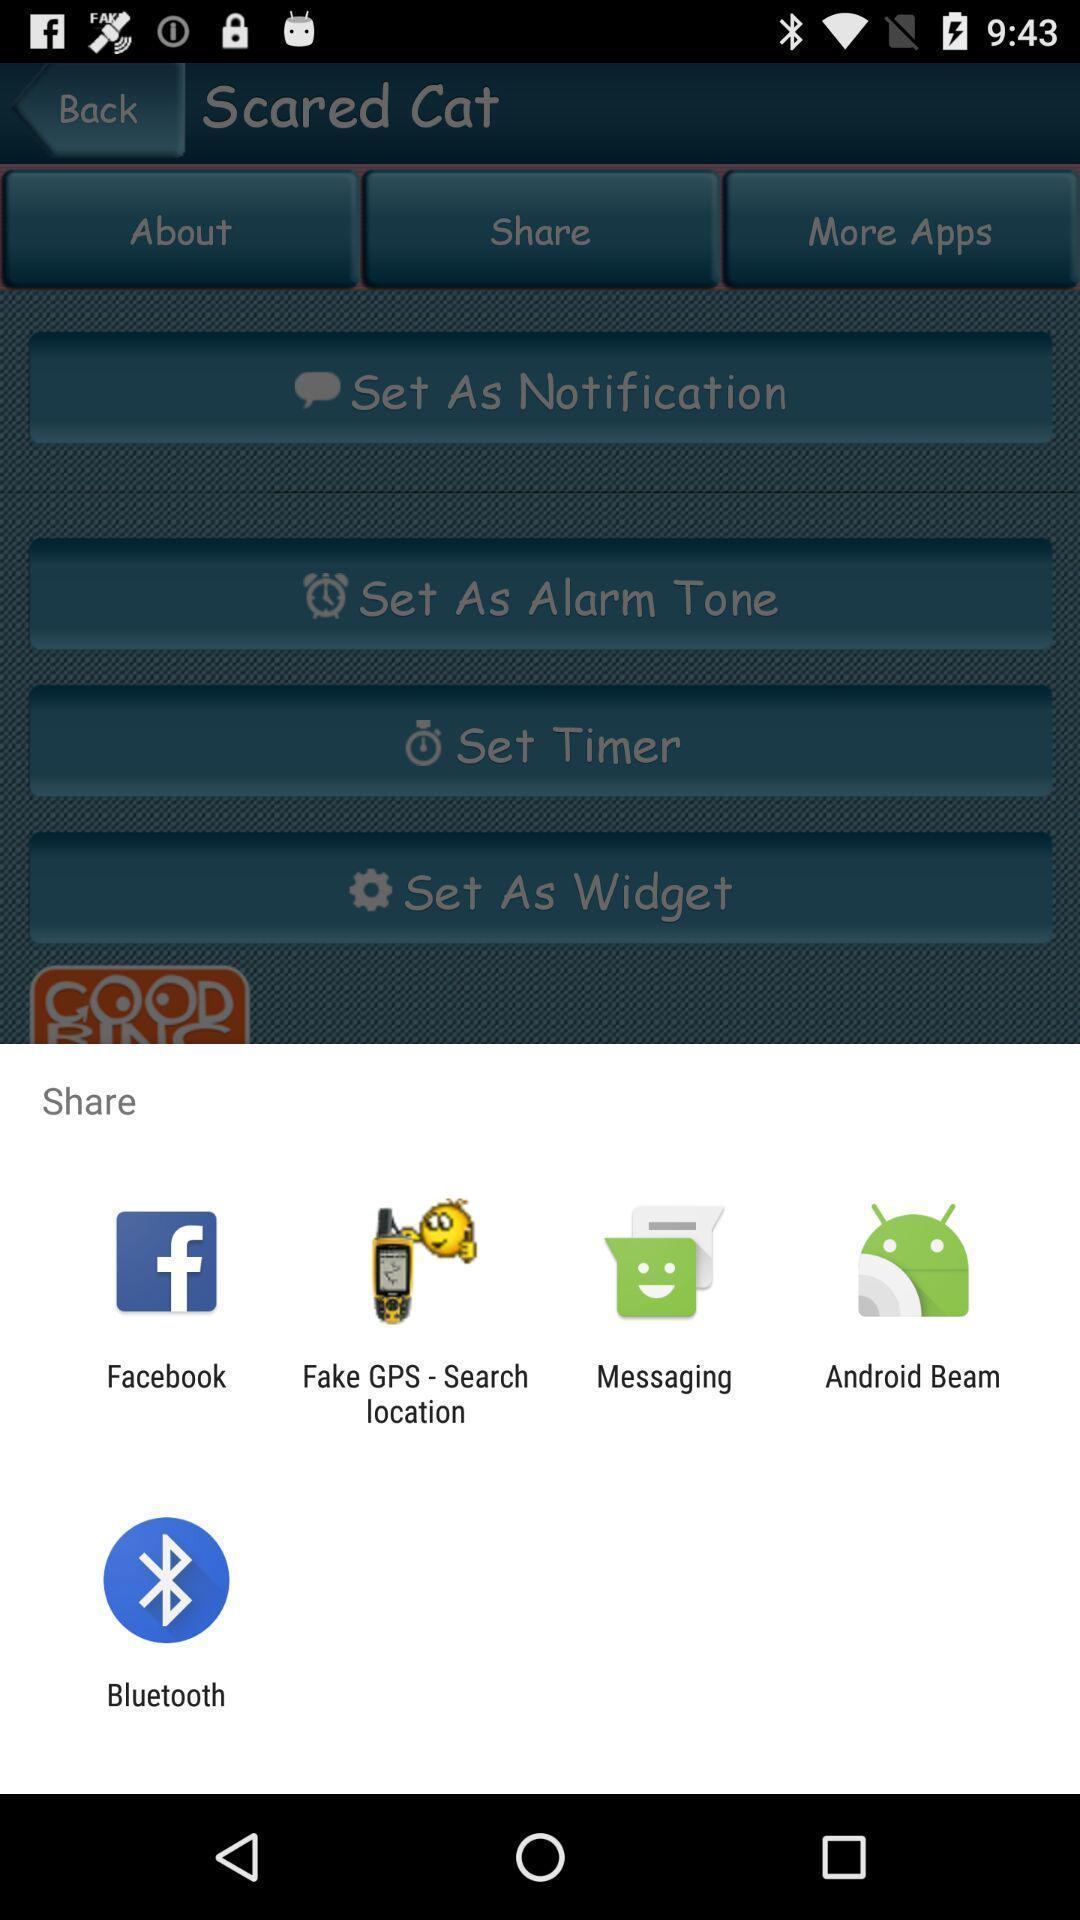Describe the key features of this screenshot. Pop-up of icons to share the ringtone app. 